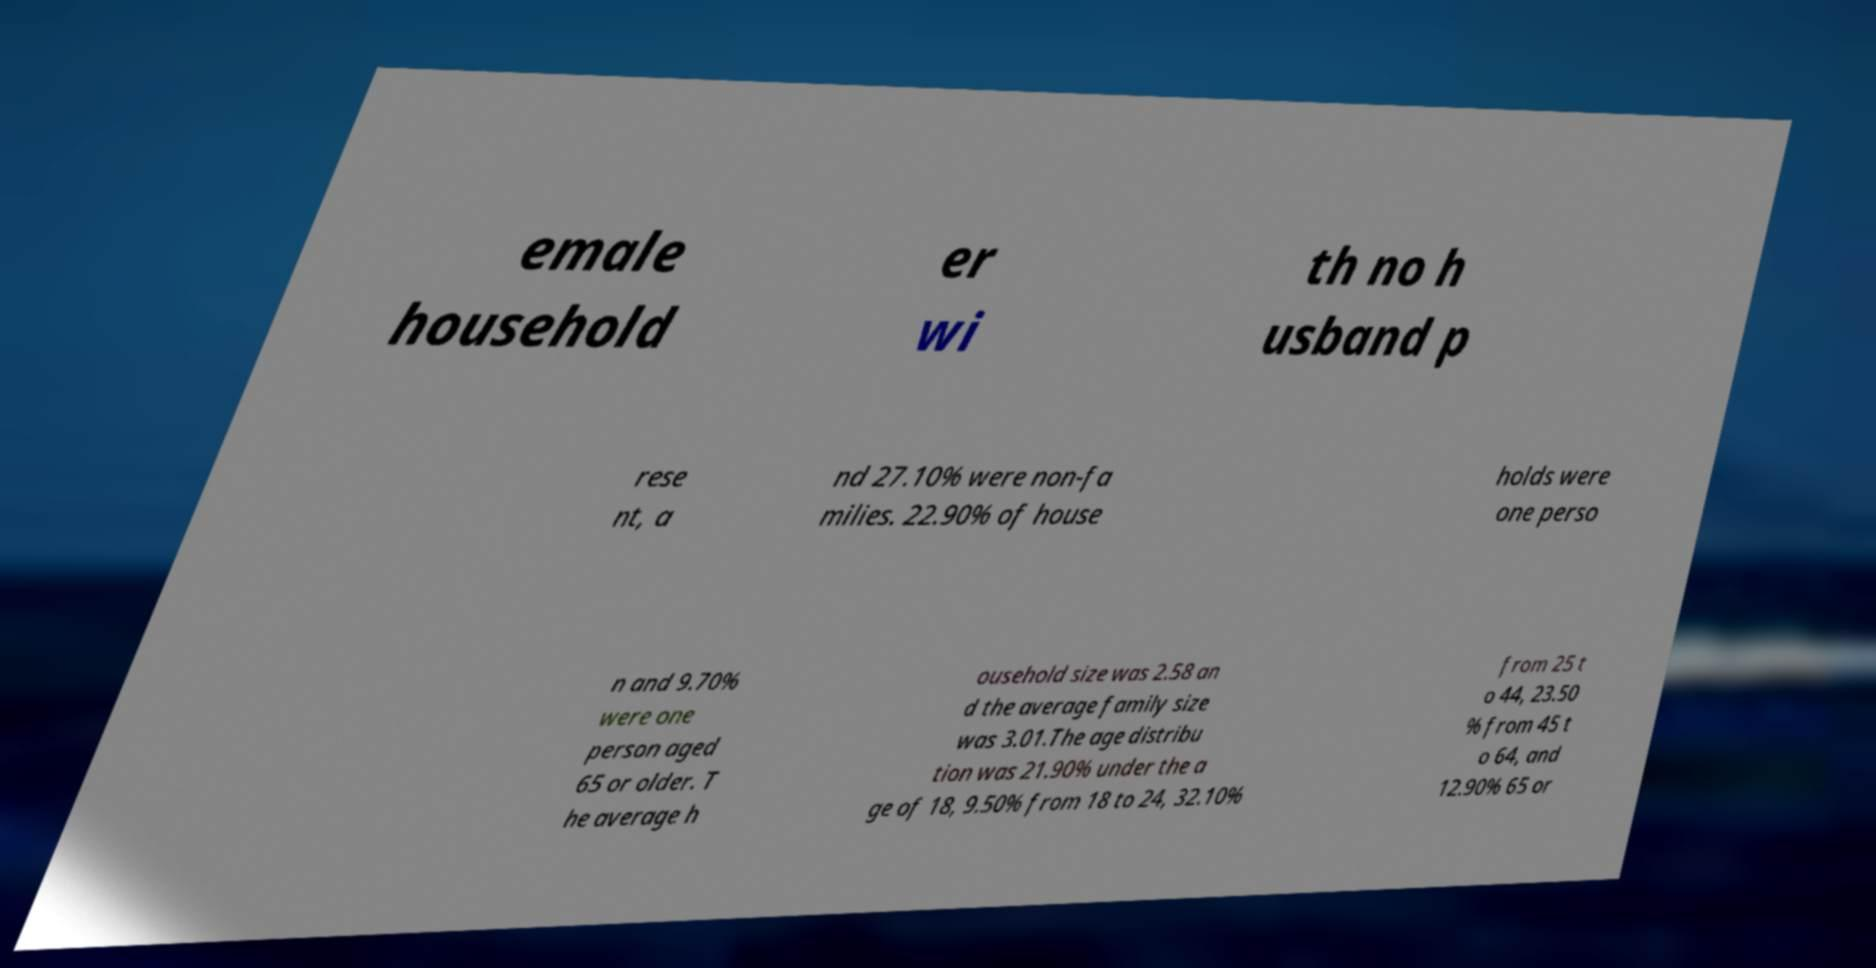Could you extract and type out the text from this image? emale household er wi th no h usband p rese nt, a nd 27.10% were non-fa milies. 22.90% of house holds were one perso n and 9.70% were one person aged 65 or older. T he average h ousehold size was 2.58 an d the average family size was 3.01.The age distribu tion was 21.90% under the a ge of 18, 9.50% from 18 to 24, 32.10% from 25 t o 44, 23.50 % from 45 t o 64, and 12.90% 65 or 